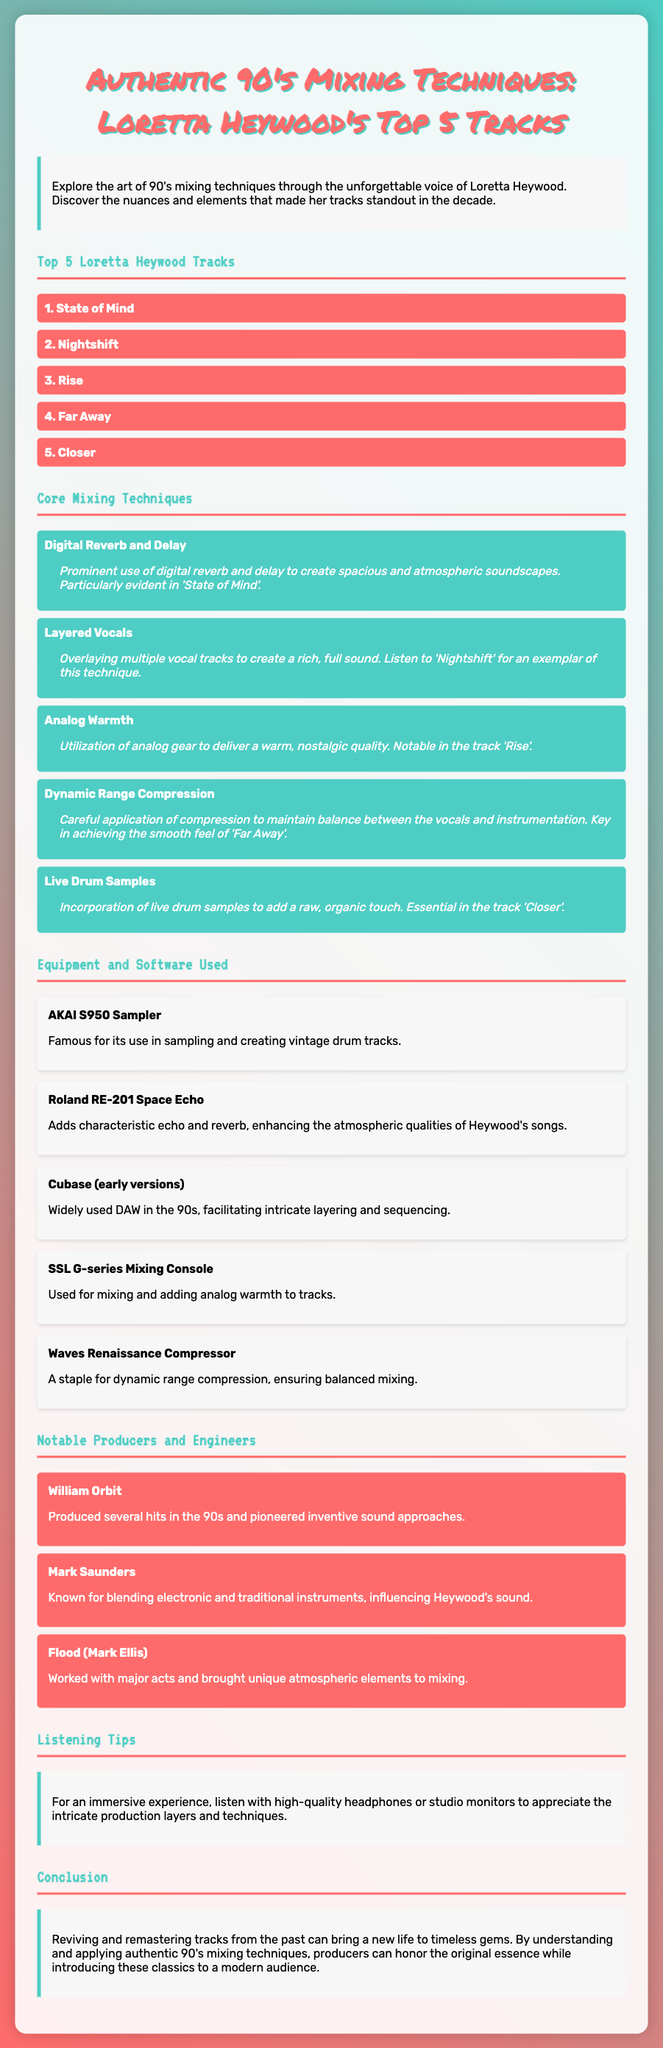What are the top 5 tracks by Loretta Heywood? The top 5 tracks are listed in the document, showcasing the main content about Loretta Heywood.
Answer: State of Mind, Nightshift, Rise, Far Away, Closer Which mixing technique is noted for creating atmospheric soundscapes? The document specifies a particular mixing technique related to creating space in sound, specifically mentioning 'State of Mind'.
Answer: Digital Reverb and Delay Who produced several hits in the 90's according to the document? A notable producer is mentioned in the context of the document, emphasizing contributions to the 90's music scene.
Answer: William Orbit What is the notable equipment used for mixing according to the equipment list? The equipment list outlines significant tools and software that contributed to the sound of Loretta Heywood's music.
Answer: SSL G-series Mixing Console Which track exemplifies the use of layered vocals? The document cites a track that showcases the technique of overlaying multiple vocal tracks for a richer sound.
Answer: Nightshift What type of listening tips does the document suggest for an immersive experience? The document provides advice on how to best experience the tracks, emphasizing audio quality.
Answer: High-quality headphones or studio monitors How many techniques are listed in the core mixing techniques section? The document outlines several specific techniques, each associated with Loretta Heywood's music.
Answer: Five What genre largely characterizes Loretta Heywood's music in the document? While the document doesn't explicitly define a genre, the context and elements suggest a stylistic approach during the 90's.
Answer: Pop/Soul Which track features analog warmth as a notable characteristic? The document identifies a particular track that is associated with the warmth provided by analog gear.
Answer: Rise 